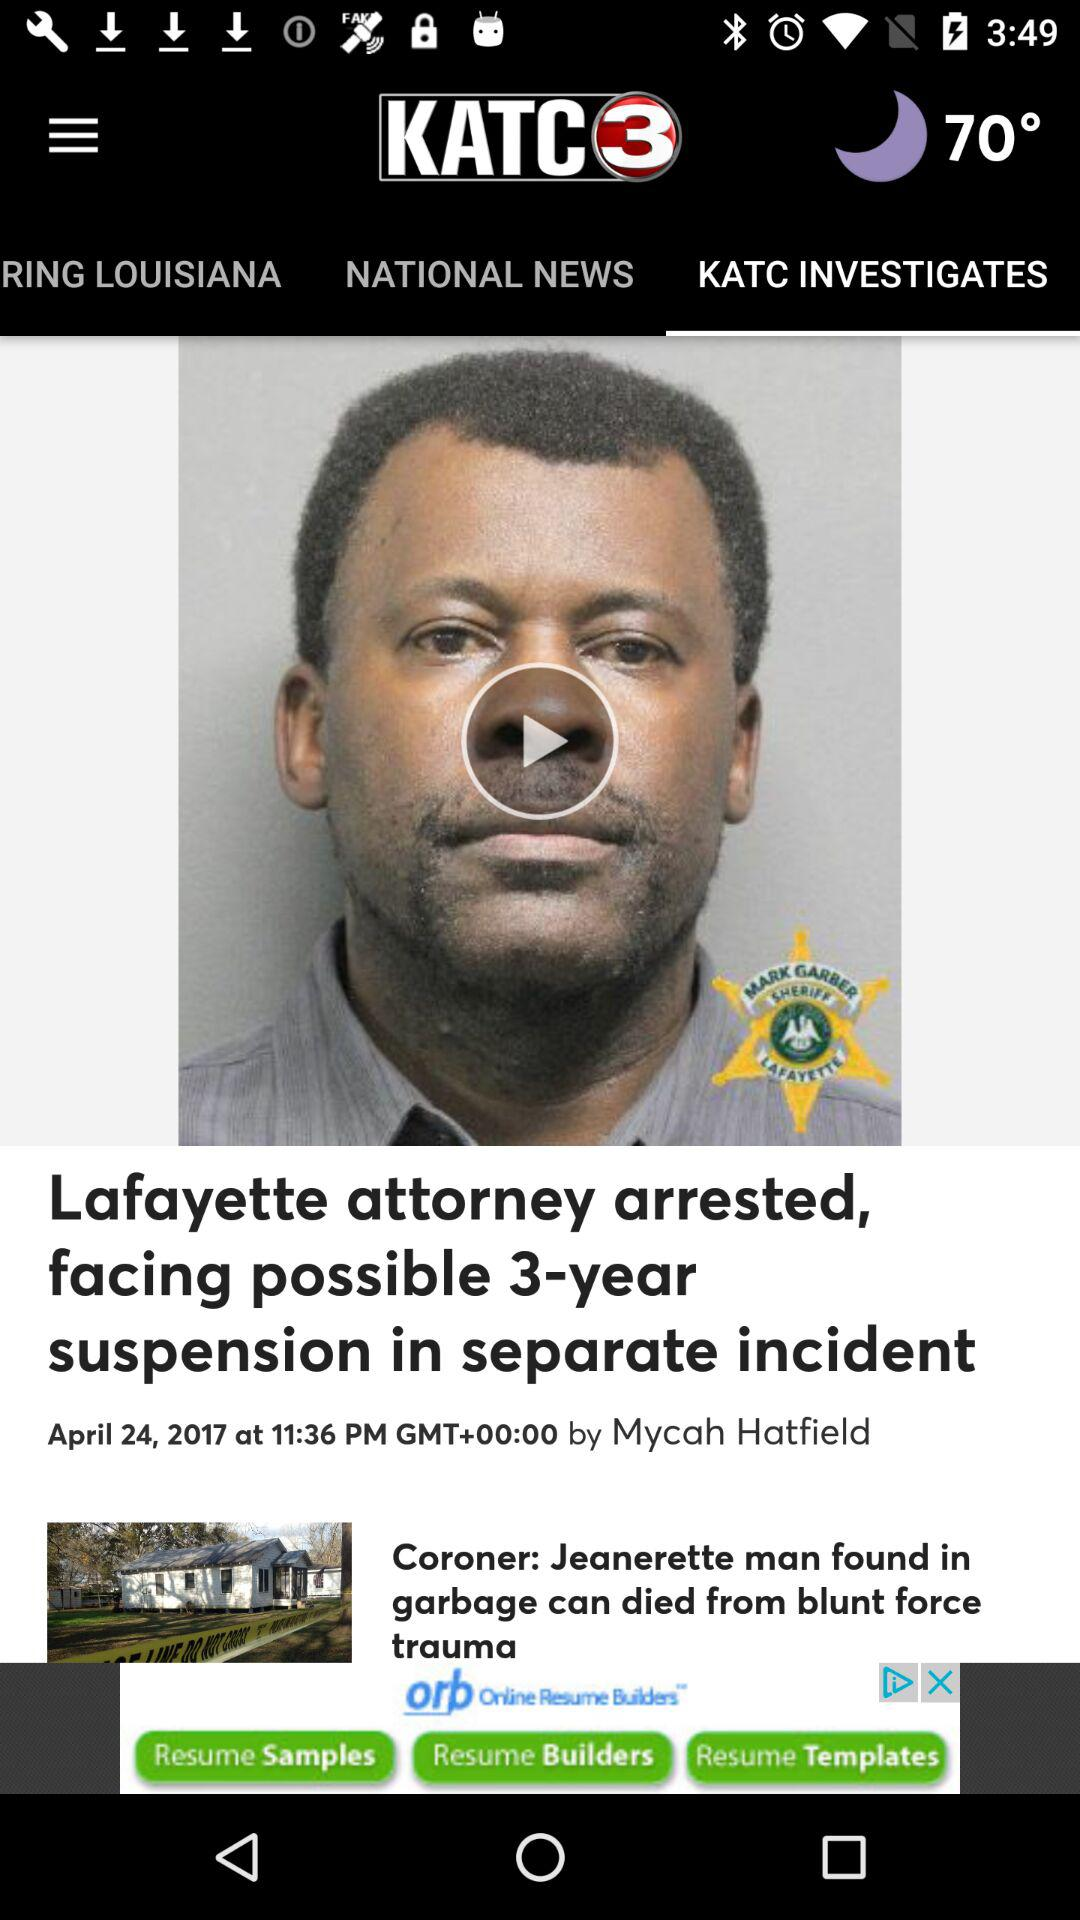At what date is the news investigation about "Lafayette attorney arrested, facing possible 3-year suspension in separate incident" posted? The date on which the news investigation about "Lafayette attorney arrested, facing possible 3-year suspension in separate incident" was posted is April 24, 2017. 